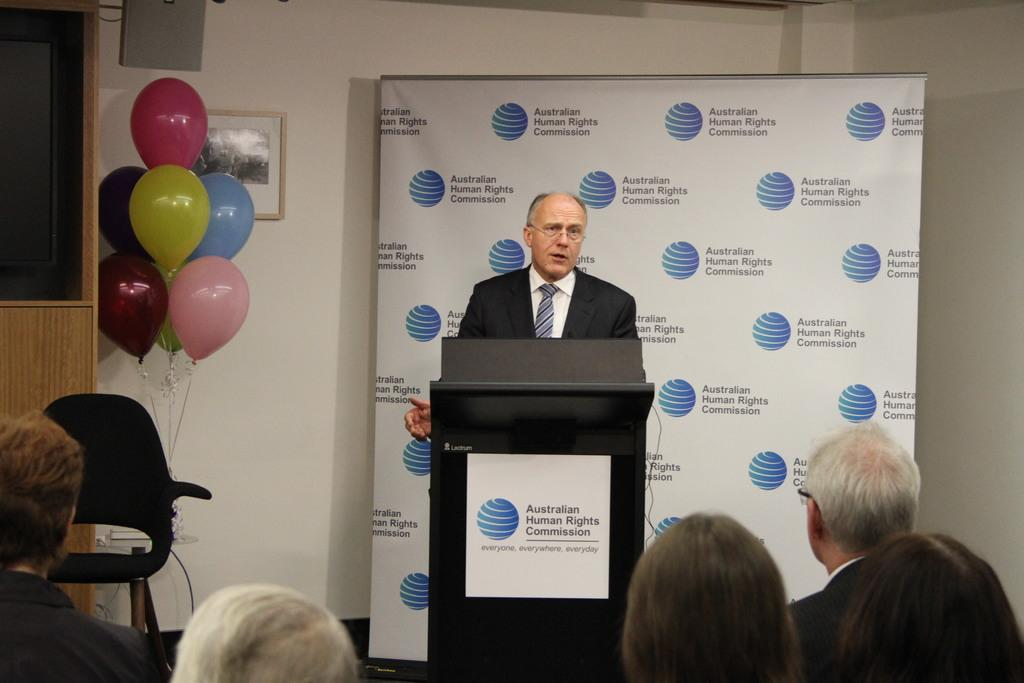<image>
Relay a brief, clear account of the picture shown. Man giving a speech in front of a sign that says Austalian Human Rights Commission. 